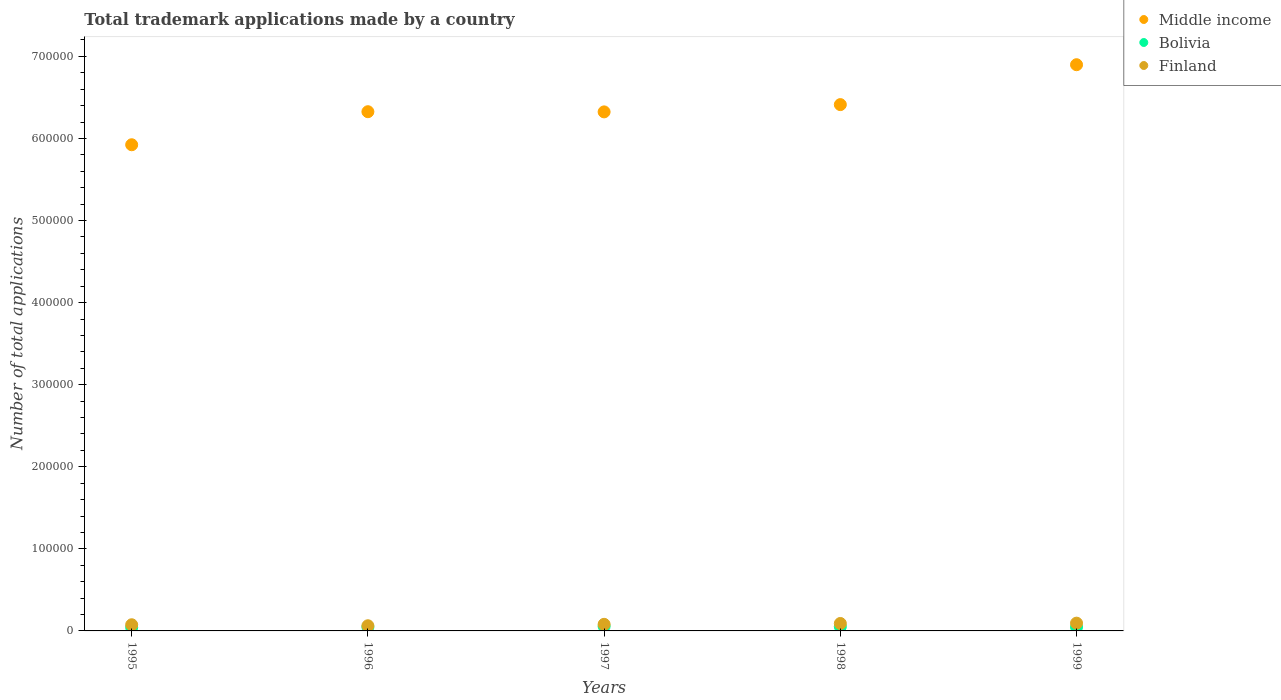What is the number of applications made by in Middle income in 1995?
Keep it short and to the point. 5.92e+05. Across all years, what is the maximum number of applications made by in Finland?
Offer a terse response. 9471. Across all years, what is the minimum number of applications made by in Finland?
Provide a succinct answer. 6297. What is the total number of applications made by in Finland in the graph?
Ensure brevity in your answer.  4.04e+04. What is the difference between the number of applications made by in Middle income in 1995 and that in 1999?
Give a very brief answer. -9.75e+04. What is the difference between the number of applications made by in Finland in 1997 and the number of applications made by in Middle income in 1996?
Provide a succinct answer. -6.25e+05. What is the average number of applications made by in Middle income per year?
Your response must be concise. 6.38e+05. In the year 1997, what is the difference between the number of applications made by in Middle income and number of applications made by in Bolivia?
Give a very brief answer. 6.27e+05. In how many years, is the number of applications made by in Bolivia greater than 140000?
Give a very brief answer. 0. What is the ratio of the number of applications made by in Finland in 1996 to that in 1997?
Give a very brief answer. 0.78. Is the number of applications made by in Bolivia in 1997 less than that in 1999?
Your answer should be compact. No. Is the difference between the number of applications made by in Middle income in 1997 and 1998 greater than the difference between the number of applications made by in Bolivia in 1997 and 1998?
Ensure brevity in your answer.  No. What is the difference between the highest and the second highest number of applications made by in Bolivia?
Make the answer very short. 405. What is the difference between the highest and the lowest number of applications made by in Bolivia?
Offer a very short reply. 1366. Is the sum of the number of applications made by in Bolivia in 1995 and 1996 greater than the maximum number of applications made by in Finland across all years?
Offer a terse response. No. Is the number of applications made by in Middle income strictly greater than the number of applications made by in Finland over the years?
Provide a succinct answer. Yes. Is the number of applications made by in Bolivia strictly less than the number of applications made by in Middle income over the years?
Give a very brief answer. Yes. How many dotlines are there?
Provide a short and direct response. 3. What is the difference between two consecutive major ticks on the Y-axis?
Ensure brevity in your answer.  1.00e+05. Are the values on the major ticks of Y-axis written in scientific E-notation?
Your answer should be very brief. No. Does the graph contain grids?
Give a very brief answer. No. How many legend labels are there?
Offer a terse response. 3. What is the title of the graph?
Offer a terse response. Total trademark applications made by a country. What is the label or title of the X-axis?
Your answer should be very brief. Years. What is the label or title of the Y-axis?
Offer a terse response. Number of total applications. What is the Number of total applications of Middle income in 1995?
Your answer should be compact. 5.92e+05. What is the Number of total applications in Bolivia in 1995?
Keep it short and to the point. 4188. What is the Number of total applications of Finland in 1995?
Your answer should be very brief. 7508. What is the Number of total applications of Middle income in 1996?
Keep it short and to the point. 6.33e+05. What is the Number of total applications in Bolivia in 1996?
Your answer should be very brief. 4684. What is the Number of total applications in Finland in 1996?
Make the answer very short. 6297. What is the Number of total applications in Middle income in 1997?
Offer a very short reply. 6.32e+05. What is the Number of total applications of Bolivia in 1997?
Offer a very short reply. 5554. What is the Number of total applications of Finland in 1997?
Make the answer very short. 8035. What is the Number of total applications in Middle income in 1998?
Give a very brief answer. 6.41e+05. What is the Number of total applications in Bolivia in 1998?
Provide a short and direct response. 5149. What is the Number of total applications in Finland in 1998?
Provide a short and direct response. 9064. What is the Number of total applications of Middle income in 1999?
Give a very brief answer. 6.90e+05. What is the Number of total applications in Bolivia in 1999?
Your response must be concise. 4719. What is the Number of total applications of Finland in 1999?
Your response must be concise. 9471. Across all years, what is the maximum Number of total applications in Middle income?
Provide a succinct answer. 6.90e+05. Across all years, what is the maximum Number of total applications in Bolivia?
Provide a short and direct response. 5554. Across all years, what is the maximum Number of total applications of Finland?
Your answer should be compact. 9471. Across all years, what is the minimum Number of total applications in Middle income?
Keep it short and to the point. 5.92e+05. Across all years, what is the minimum Number of total applications in Bolivia?
Provide a succinct answer. 4188. Across all years, what is the minimum Number of total applications in Finland?
Offer a very short reply. 6297. What is the total Number of total applications of Middle income in the graph?
Provide a succinct answer. 3.19e+06. What is the total Number of total applications in Bolivia in the graph?
Your answer should be compact. 2.43e+04. What is the total Number of total applications of Finland in the graph?
Offer a very short reply. 4.04e+04. What is the difference between the Number of total applications in Middle income in 1995 and that in 1996?
Your answer should be compact. -4.03e+04. What is the difference between the Number of total applications of Bolivia in 1995 and that in 1996?
Offer a terse response. -496. What is the difference between the Number of total applications of Finland in 1995 and that in 1996?
Provide a short and direct response. 1211. What is the difference between the Number of total applications of Middle income in 1995 and that in 1997?
Provide a short and direct response. -4.00e+04. What is the difference between the Number of total applications of Bolivia in 1995 and that in 1997?
Give a very brief answer. -1366. What is the difference between the Number of total applications in Finland in 1995 and that in 1997?
Offer a terse response. -527. What is the difference between the Number of total applications of Middle income in 1995 and that in 1998?
Your answer should be very brief. -4.89e+04. What is the difference between the Number of total applications in Bolivia in 1995 and that in 1998?
Make the answer very short. -961. What is the difference between the Number of total applications of Finland in 1995 and that in 1998?
Give a very brief answer. -1556. What is the difference between the Number of total applications of Middle income in 1995 and that in 1999?
Your answer should be very brief. -9.75e+04. What is the difference between the Number of total applications of Bolivia in 1995 and that in 1999?
Make the answer very short. -531. What is the difference between the Number of total applications of Finland in 1995 and that in 1999?
Your answer should be very brief. -1963. What is the difference between the Number of total applications in Middle income in 1996 and that in 1997?
Your response must be concise. 223. What is the difference between the Number of total applications of Bolivia in 1996 and that in 1997?
Keep it short and to the point. -870. What is the difference between the Number of total applications in Finland in 1996 and that in 1997?
Ensure brevity in your answer.  -1738. What is the difference between the Number of total applications of Middle income in 1996 and that in 1998?
Offer a terse response. -8640. What is the difference between the Number of total applications in Bolivia in 1996 and that in 1998?
Offer a very short reply. -465. What is the difference between the Number of total applications in Finland in 1996 and that in 1998?
Provide a succinct answer. -2767. What is the difference between the Number of total applications of Middle income in 1996 and that in 1999?
Your answer should be very brief. -5.72e+04. What is the difference between the Number of total applications in Bolivia in 1996 and that in 1999?
Give a very brief answer. -35. What is the difference between the Number of total applications of Finland in 1996 and that in 1999?
Give a very brief answer. -3174. What is the difference between the Number of total applications in Middle income in 1997 and that in 1998?
Make the answer very short. -8863. What is the difference between the Number of total applications of Bolivia in 1997 and that in 1998?
Provide a succinct answer. 405. What is the difference between the Number of total applications in Finland in 1997 and that in 1998?
Your answer should be very brief. -1029. What is the difference between the Number of total applications of Middle income in 1997 and that in 1999?
Give a very brief answer. -5.75e+04. What is the difference between the Number of total applications in Bolivia in 1997 and that in 1999?
Your answer should be very brief. 835. What is the difference between the Number of total applications of Finland in 1997 and that in 1999?
Your answer should be compact. -1436. What is the difference between the Number of total applications in Middle income in 1998 and that in 1999?
Give a very brief answer. -4.86e+04. What is the difference between the Number of total applications in Bolivia in 1998 and that in 1999?
Make the answer very short. 430. What is the difference between the Number of total applications of Finland in 1998 and that in 1999?
Give a very brief answer. -407. What is the difference between the Number of total applications in Middle income in 1995 and the Number of total applications in Bolivia in 1996?
Ensure brevity in your answer.  5.88e+05. What is the difference between the Number of total applications of Middle income in 1995 and the Number of total applications of Finland in 1996?
Offer a very short reply. 5.86e+05. What is the difference between the Number of total applications of Bolivia in 1995 and the Number of total applications of Finland in 1996?
Offer a very short reply. -2109. What is the difference between the Number of total applications of Middle income in 1995 and the Number of total applications of Bolivia in 1997?
Your answer should be compact. 5.87e+05. What is the difference between the Number of total applications in Middle income in 1995 and the Number of total applications in Finland in 1997?
Your answer should be very brief. 5.84e+05. What is the difference between the Number of total applications of Bolivia in 1995 and the Number of total applications of Finland in 1997?
Make the answer very short. -3847. What is the difference between the Number of total applications of Middle income in 1995 and the Number of total applications of Bolivia in 1998?
Offer a terse response. 5.87e+05. What is the difference between the Number of total applications of Middle income in 1995 and the Number of total applications of Finland in 1998?
Your answer should be compact. 5.83e+05. What is the difference between the Number of total applications in Bolivia in 1995 and the Number of total applications in Finland in 1998?
Offer a very short reply. -4876. What is the difference between the Number of total applications in Middle income in 1995 and the Number of total applications in Bolivia in 1999?
Provide a succinct answer. 5.88e+05. What is the difference between the Number of total applications of Middle income in 1995 and the Number of total applications of Finland in 1999?
Make the answer very short. 5.83e+05. What is the difference between the Number of total applications in Bolivia in 1995 and the Number of total applications in Finland in 1999?
Your answer should be very brief. -5283. What is the difference between the Number of total applications of Middle income in 1996 and the Number of total applications of Bolivia in 1997?
Offer a very short reply. 6.27e+05. What is the difference between the Number of total applications in Middle income in 1996 and the Number of total applications in Finland in 1997?
Your response must be concise. 6.25e+05. What is the difference between the Number of total applications of Bolivia in 1996 and the Number of total applications of Finland in 1997?
Ensure brevity in your answer.  -3351. What is the difference between the Number of total applications of Middle income in 1996 and the Number of total applications of Bolivia in 1998?
Provide a short and direct response. 6.27e+05. What is the difference between the Number of total applications of Middle income in 1996 and the Number of total applications of Finland in 1998?
Your response must be concise. 6.23e+05. What is the difference between the Number of total applications of Bolivia in 1996 and the Number of total applications of Finland in 1998?
Ensure brevity in your answer.  -4380. What is the difference between the Number of total applications of Middle income in 1996 and the Number of total applications of Bolivia in 1999?
Keep it short and to the point. 6.28e+05. What is the difference between the Number of total applications in Middle income in 1996 and the Number of total applications in Finland in 1999?
Provide a succinct answer. 6.23e+05. What is the difference between the Number of total applications in Bolivia in 1996 and the Number of total applications in Finland in 1999?
Your answer should be compact. -4787. What is the difference between the Number of total applications in Middle income in 1997 and the Number of total applications in Bolivia in 1998?
Your answer should be compact. 6.27e+05. What is the difference between the Number of total applications in Middle income in 1997 and the Number of total applications in Finland in 1998?
Provide a succinct answer. 6.23e+05. What is the difference between the Number of total applications of Bolivia in 1997 and the Number of total applications of Finland in 1998?
Provide a short and direct response. -3510. What is the difference between the Number of total applications of Middle income in 1997 and the Number of total applications of Bolivia in 1999?
Your response must be concise. 6.28e+05. What is the difference between the Number of total applications of Middle income in 1997 and the Number of total applications of Finland in 1999?
Provide a short and direct response. 6.23e+05. What is the difference between the Number of total applications of Bolivia in 1997 and the Number of total applications of Finland in 1999?
Provide a short and direct response. -3917. What is the difference between the Number of total applications in Middle income in 1998 and the Number of total applications in Bolivia in 1999?
Your response must be concise. 6.36e+05. What is the difference between the Number of total applications of Middle income in 1998 and the Number of total applications of Finland in 1999?
Offer a terse response. 6.32e+05. What is the difference between the Number of total applications of Bolivia in 1998 and the Number of total applications of Finland in 1999?
Offer a very short reply. -4322. What is the average Number of total applications in Middle income per year?
Give a very brief answer. 6.38e+05. What is the average Number of total applications in Bolivia per year?
Your answer should be very brief. 4858.8. What is the average Number of total applications in Finland per year?
Your answer should be compact. 8075. In the year 1995, what is the difference between the Number of total applications in Middle income and Number of total applications in Bolivia?
Your response must be concise. 5.88e+05. In the year 1995, what is the difference between the Number of total applications in Middle income and Number of total applications in Finland?
Offer a terse response. 5.85e+05. In the year 1995, what is the difference between the Number of total applications in Bolivia and Number of total applications in Finland?
Provide a short and direct response. -3320. In the year 1996, what is the difference between the Number of total applications in Middle income and Number of total applications in Bolivia?
Provide a short and direct response. 6.28e+05. In the year 1996, what is the difference between the Number of total applications in Middle income and Number of total applications in Finland?
Ensure brevity in your answer.  6.26e+05. In the year 1996, what is the difference between the Number of total applications of Bolivia and Number of total applications of Finland?
Provide a short and direct response. -1613. In the year 1997, what is the difference between the Number of total applications of Middle income and Number of total applications of Bolivia?
Offer a very short reply. 6.27e+05. In the year 1997, what is the difference between the Number of total applications of Middle income and Number of total applications of Finland?
Your answer should be compact. 6.24e+05. In the year 1997, what is the difference between the Number of total applications in Bolivia and Number of total applications in Finland?
Ensure brevity in your answer.  -2481. In the year 1998, what is the difference between the Number of total applications in Middle income and Number of total applications in Bolivia?
Provide a succinct answer. 6.36e+05. In the year 1998, what is the difference between the Number of total applications of Middle income and Number of total applications of Finland?
Provide a short and direct response. 6.32e+05. In the year 1998, what is the difference between the Number of total applications of Bolivia and Number of total applications of Finland?
Keep it short and to the point. -3915. In the year 1999, what is the difference between the Number of total applications of Middle income and Number of total applications of Bolivia?
Your answer should be compact. 6.85e+05. In the year 1999, what is the difference between the Number of total applications in Middle income and Number of total applications in Finland?
Offer a terse response. 6.80e+05. In the year 1999, what is the difference between the Number of total applications of Bolivia and Number of total applications of Finland?
Your response must be concise. -4752. What is the ratio of the Number of total applications of Middle income in 1995 to that in 1996?
Make the answer very short. 0.94. What is the ratio of the Number of total applications in Bolivia in 1995 to that in 1996?
Provide a succinct answer. 0.89. What is the ratio of the Number of total applications in Finland in 1995 to that in 1996?
Make the answer very short. 1.19. What is the ratio of the Number of total applications of Middle income in 1995 to that in 1997?
Offer a very short reply. 0.94. What is the ratio of the Number of total applications of Bolivia in 1995 to that in 1997?
Your answer should be very brief. 0.75. What is the ratio of the Number of total applications in Finland in 1995 to that in 1997?
Give a very brief answer. 0.93. What is the ratio of the Number of total applications of Middle income in 1995 to that in 1998?
Offer a terse response. 0.92. What is the ratio of the Number of total applications of Bolivia in 1995 to that in 1998?
Your response must be concise. 0.81. What is the ratio of the Number of total applications of Finland in 1995 to that in 1998?
Give a very brief answer. 0.83. What is the ratio of the Number of total applications in Middle income in 1995 to that in 1999?
Your answer should be compact. 0.86. What is the ratio of the Number of total applications of Bolivia in 1995 to that in 1999?
Keep it short and to the point. 0.89. What is the ratio of the Number of total applications in Finland in 1995 to that in 1999?
Provide a succinct answer. 0.79. What is the ratio of the Number of total applications in Bolivia in 1996 to that in 1997?
Offer a terse response. 0.84. What is the ratio of the Number of total applications in Finland in 1996 to that in 1997?
Your answer should be very brief. 0.78. What is the ratio of the Number of total applications in Middle income in 1996 to that in 1998?
Ensure brevity in your answer.  0.99. What is the ratio of the Number of total applications in Bolivia in 1996 to that in 1998?
Ensure brevity in your answer.  0.91. What is the ratio of the Number of total applications in Finland in 1996 to that in 1998?
Your answer should be very brief. 0.69. What is the ratio of the Number of total applications of Middle income in 1996 to that in 1999?
Offer a terse response. 0.92. What is the ratio of the Number of total applications in Bolivia in 1996 to that in 1999?
Your response must be concise. 0.99. What is the ratio of the Number of total applications of Finland in 1996 to that in 1999?
Give a very brief answer. 0.66. What is the ratio of the Number of total applications of Middle income in 1997 to that in 1998?
Offer a terse response. 0.99. What is the ratio of the Number of total applications of Bolivia in 1997 to that in 1998?
Offer a terse response. 1.08. What is the ratio of the Number of total applications of Finland in 1997 to that in 1998?
Make the answer very short. 0.89. What is the ratio of the Number of total applications of Bolivia in 1997 to that in 1999?
Your response must be concise. 1.18. What is the ratio of the Number of total applications of Finland in 1997 to that in 1999?
Keep it short and to the point. 0.85. What is the ratio of the Number of total applications of Middle income in 1998 to that in 1999?
Provide a succinct answer. 0.93. What is the ratio of the Number of total applications of Bolivia in 1998 to that in 1999?
Provide a succinct answer. 1.09. What is the ratio of the Number of total applications in Finland in 1998 to that in 1999?
Give a very brief answer. 0.96. What is the difference between the highest and the second highest Number of total applications of Middle income?
Your answer should be compact. 4.86e+04. What is the difference between the highest and the second highest Number of total applications in Bolivia?
Provide a short and direct response. 405. What is the difference between the highest and the second highest Number of total applications in Finland?
Ensure brevity in your answer.  407. What is the difference between the highest and the lowest Number of total applications of Middle income?
Provide a short and direct response. 9.75e+04. What is the difference between the highest and the lowest Number of total applications of Bolivia?
Offer a terse response. 1366. What is the difference between the highest and the lowest Number of total applications of Finland?
Your answer should be very brief. 3174. 